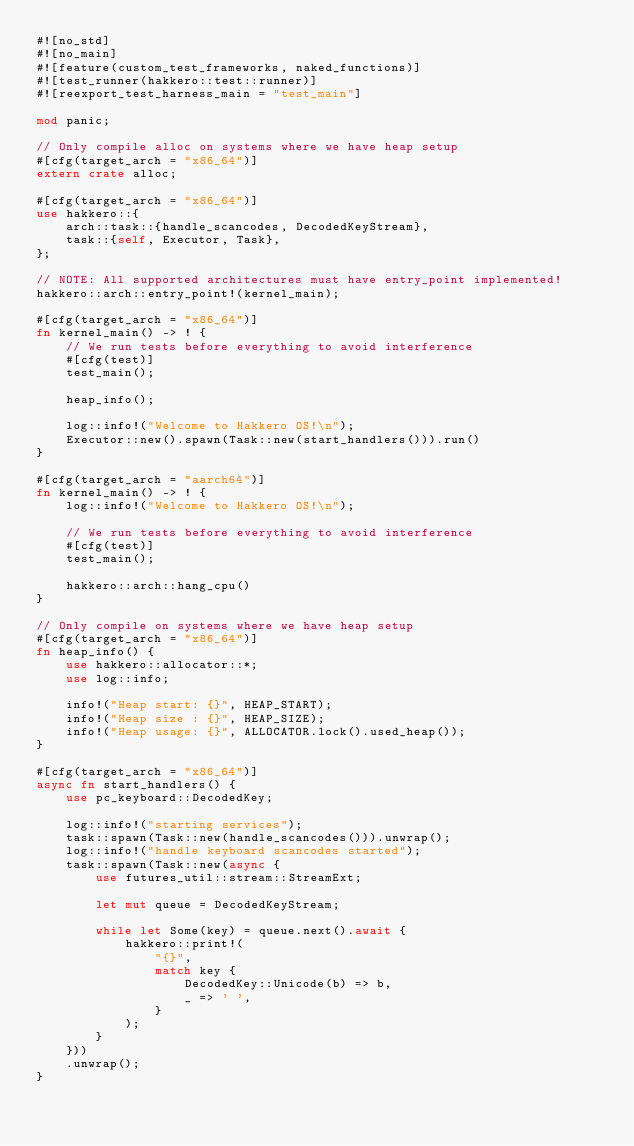<code> <loc_0><loc_0><loc_500><loc_500><_Rust_>#![no_std]
#![no_main]
#![feature(custom_test_frameworks, naked_functions)]
#![test_runner(hakkero::test::runner)]
#![reexport_test_harness_main = "test_main"]

mod panic;

// Only compile alloc on systems where we have heap setup
#[cfg(target_arch = "x86_64")]
extern crate alloc;

#[cfg(target_arch = "x86_64")]
use hakkero::{
    arch::task::{handle_scancodes, DecodedKeyStream},
    task::{self, Executor, Task},
};

// NOTE: All supported architectures must have entry_point implemented!
hakkero::arch::entry_point!(kernel_main);

#[cfg(target_arch = "x86_64")]
fn kernel_main() -> ! {
    // We run tests before everything to avoid interference
    #[cfg(test)]
    test_main();

    heap_info();

    log::info!("Welcome to Hakkero OS!\n");
    Executor::new().spawn(Task::new(start_handlers())).run()
}

#[cfg(target_arch = "aarch64")]
fn kernel_main() -> ! {
    log::info!("Welcome to Hakkero OS!\n");

    // We run tests before everything to avoid interference
    #[cfg(test)]
    test_main();

    hakkero::arch::hang_cpu()
}

// Only compile on systems where we have heap setup
#[cfg(target_arch = "x86_64")]
fn heap_info() {
    use hakkero::allocator::*;
    use log::info;

    info!("Heap start: {}", HEAP_START);
    info!("Heap size : {}", HEAP_SIZE);
    info!("Heap usage: {}", ALLOCATOR.lock().used_heap());
}

#[cfg(target_arch = "x86_64")]
async fn start_handlers() {
    use pc_keyboard::DecodedKey;

    log::info!("starting services");
    task::spawn(Task::new(handle_scancodes())).unwrap();
    log::info!("handle keyboard scancodes started");
    task::spawn(Task::new(async {
        use futures_util::stream::StreamExt;

        let mut queue = DecodedKeyStream;

        while let Some(key) = queue.next().await {
            hakkero::print!(
                "{}",
                match key {
                    DecodedKey::Unicode(b) => b,
                    _ => ' ',
                }
            );
        }
    }))
    .unwrap();
}
</code> 